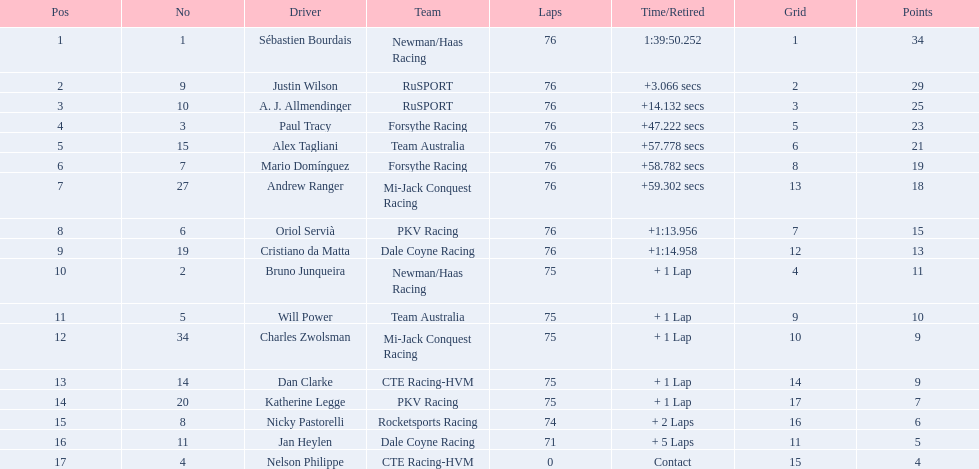Does a driver named charles zwolsman exist? Charles Zwolsman. How many points did he accumulate? 9. Were there any other contenders with the same point total? 9. Whose entry was that? Dan Clarke. 